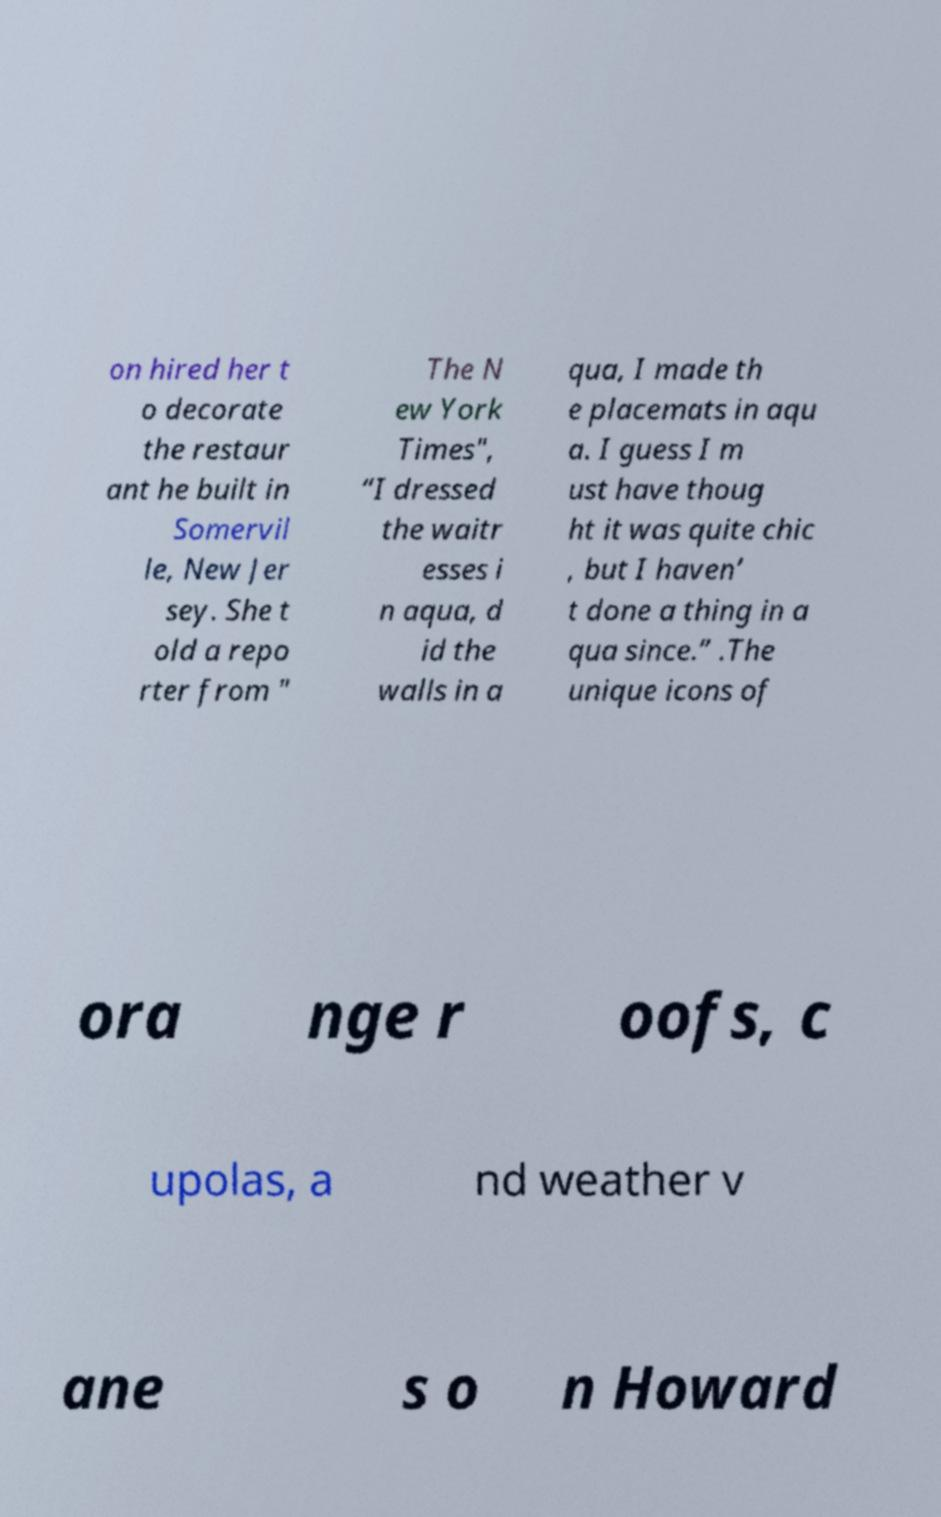Could you assist in decoding the text presented in this image and type it out clearly? on hired her t o decorate the restaur ant he built in Somervil le, New Jer sey. She t old a repo rter from " The N ew York Times", “I dressed the waitr esses i n aqua, d id the walls in a qua, I made th e placemats in aqu a. I guess I m ust have thoug ht it was quite chic , but I haven’ t done a thing in a qua since.” .The unique icons of ora nge r oofs, c upolas, a nd weather v ane s o n Howard 